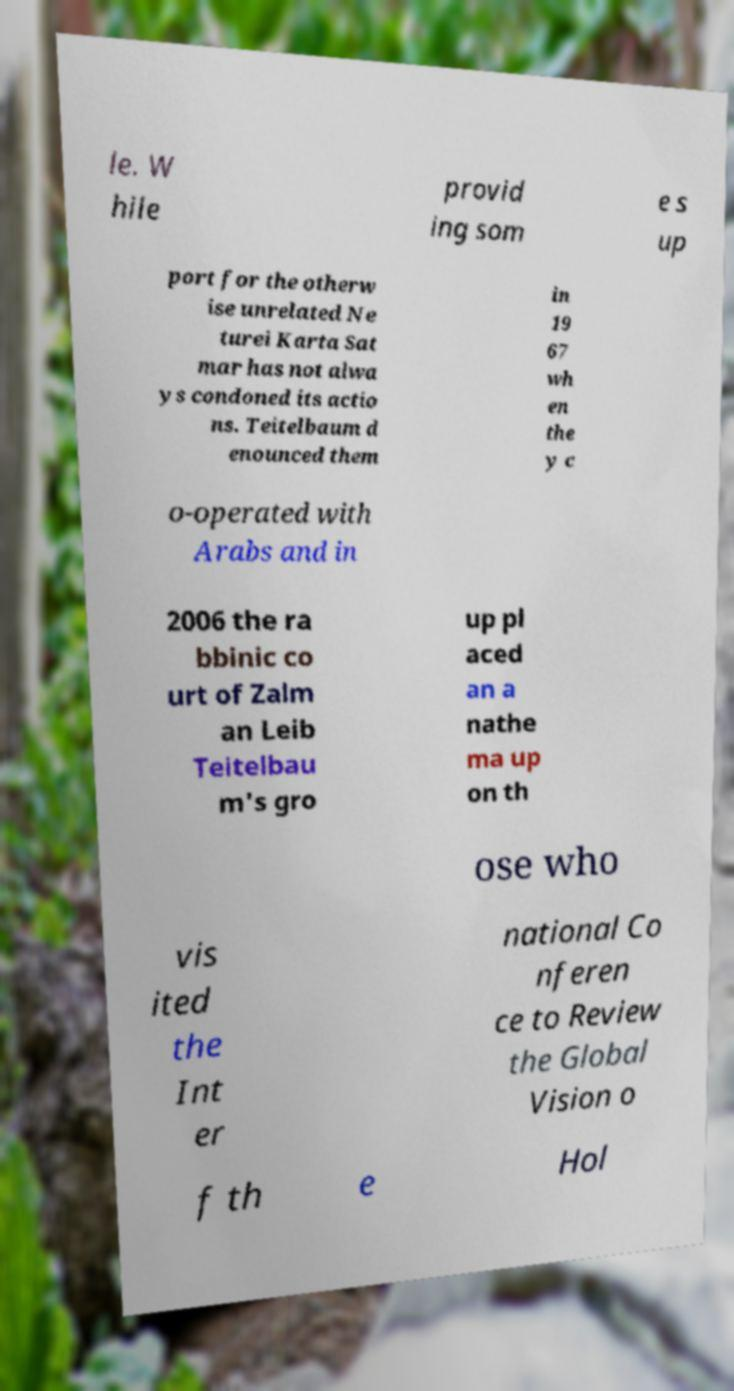Could you assist in decoding the text presented in this image and type it out clearly? le. W hile provid ing som e s up port for the otherw ise unrelated Ne turei Karta Sat mar has not alwa ys condoned its actio ns. Teitelbaum d enounced them in 19 67 wh en the y c o-operated with Arabs and in 2006 the ra bbinic co urt of Zalm an Leib Teitelbau m's gro up pl aced an a nathe ma up on th ose who vis ited the Int er national Co nferen ce to Review the Global Vision o f th e Hol 